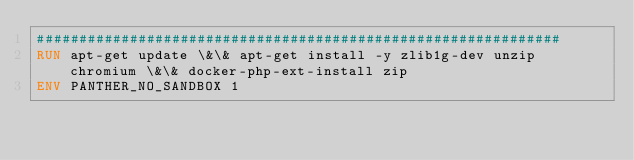<code> <loc_0><loc_0><loc_500><loc_500><_Dockerfile_>##############################################################
RUN apt-get update \&\& apt-get install -y zlib1g-dev unzip chromium \&\& docker-php-ext-install zip
ENV PANTHER_NO_SANDBOX 1
</code> 